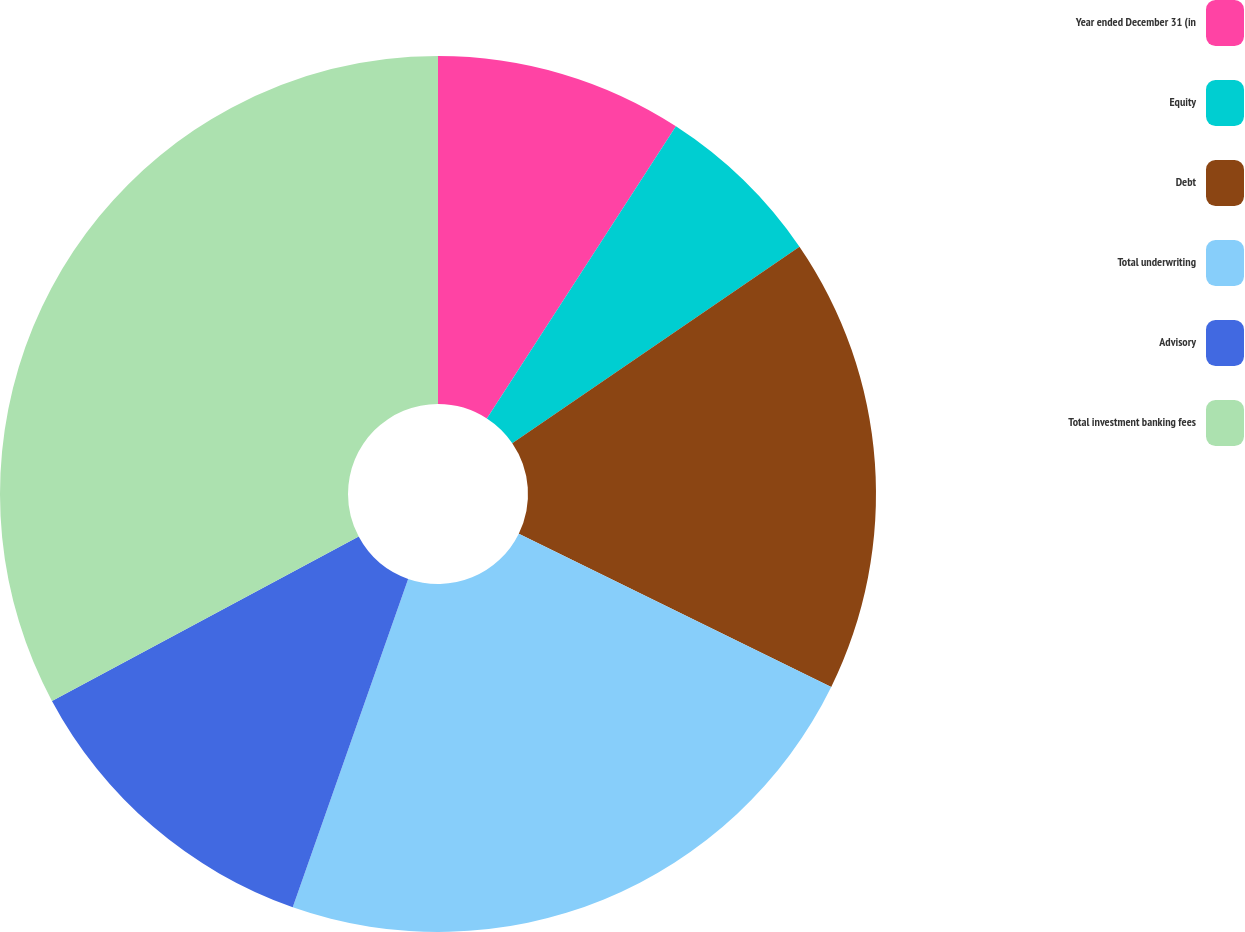Convert chart to OTSL. <chart><loc_0><loc_0><loc_500><loc_500><pie_chart><fcel>Year ended December 31 (in<fcel>Equity<fcel>Debt<fcel>Total underwriting<fcel>Advisory<fcel>Total investment banking fees<nl><fcel>9.14%<fcel>6.31%<fcel>16.81%<fcel>23.12%<fcel>11.79%<fcel>32.83%<nl></chart> 